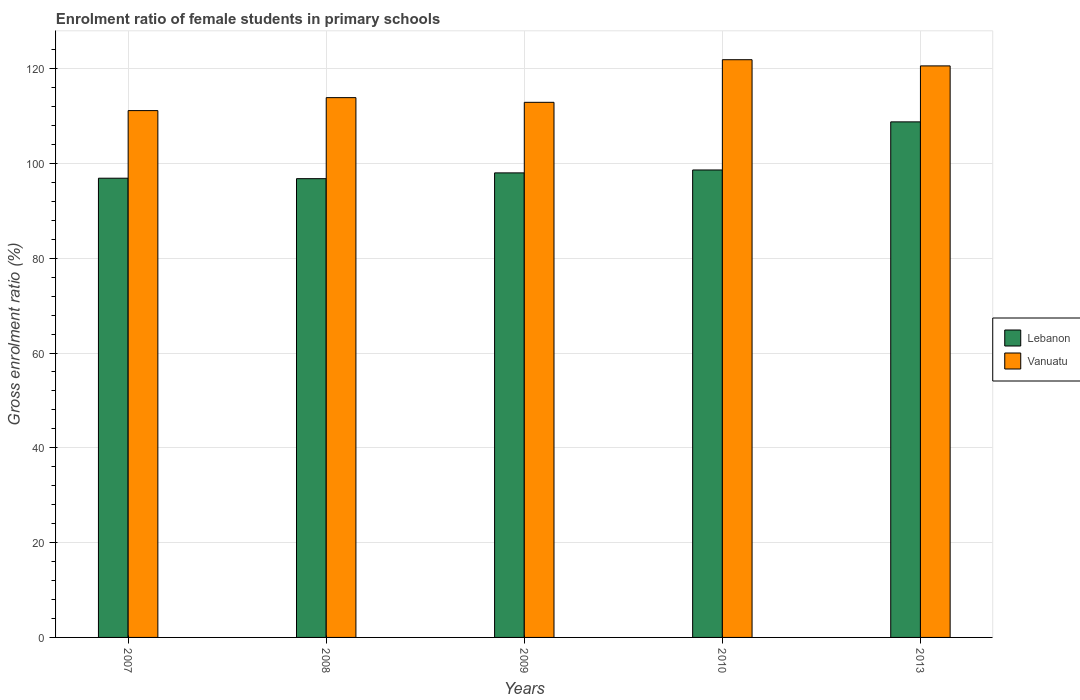How many different coloured bars are there?
Keep it short and to the point. 2. How many groups of bars are there?
Offer a very short reply. 5. How many bars are there on the 3rd tick from the right?
Make the answer very short. 2. In how many cases, is the number of bars for a given year not equal to the number of legend labels?
Offer a very short reply. 0. What is the enrolment ratio of female students in primary schools in Vanuatu in 2013?
Offer a terse response. 120.58. Across all years, what is the maximum enrolment ratio of female students in primary schools in Vanuatu?
Ensure brevity in your answer.  121.88. Across all years, what is the minimum enrolment ratio of female students in primary schools in Vanuatu?
Keep it short and to the point. 111.14. In which year was the enrolment ratio of female students in primary schools in Lebanon maximum?
Ensure brevity in your answer.  2013. In which year was the enrolment ratio of female students in primary schools in Vanuatu minimum?
Offer a terse response. 2007. What is the total enrolment ratio of female students in primary schools in Lebanon in the graph?
Keep it short and to the point. 499.07. What is the difference between the enrolment ratio of female students in primary schools in Vanuatu in 2007 and that in 2009?
Offer a terse response. -1.75. What is the difference between the enrolment ratio of female students in primary schools in Vanuatu in 2010 and the enrolment ratio of female students in primary schools in Lebanon in 2009?
Your answer should be very brief. 23.88. What is the average enrolment ratio of female students in primary schools in Lebanon per year?
Your answer should be very brief. 99.81. In the year 2007, what is the difference between the enrolment ratio of female students in primary schools in Lebanon and enrolment ratio of female students in primary schools in Vanuatu?
Provide a short and direct response. -14.26. In how many years, is the enrolment ratio of female students in primary schools in Vanuatu greater than 20 %?
Your answer should be compact. 5. What is the ratio of the enrolment ratio of female students in primary schools in Vanuatu in 2007 to that in 2008?
Ensure brevity in your answer.  0.98. What is the difference between the highest and the second highest enrolment ratio of female students in primary schools in Vanuatu?
Offer a very short reply. 1.31. What is the difference between the highest and the lowest enrolment ratio of female students in primary schools in Vanuatu?
Your answer should be very brief. 10.74. Is the sum of the enrolment ratio of female students in primary schools in Lebanon in 2008 and 2013 greater than the maximum enrolment ratio of female students in primary schools in Vanuatu across all years?
Your answer should be compact. Yes. What does the 2nd bar from the left in 2010 represents?
Your answer should be very brief. Vanuatu. What does the 1st bar from the right in 2007 represents?
Ensure brevity in your answer.  Vanuatu. Are all the bars in the graph horizontal?
Ensure brevity in your answer.  No. What is the difference between two consecutive major ticks on the Y-axis?
Give a very brief answer. 20. Are the values on the major ticks of Y-axis written in scientific E-notation?
Your answer should be very brief. No. Does the graph contain any zero values?
Your answer should be very brief. No. How many legend labels are there?
Make the answer very short. 2. How are the legend labels stacked?
Keep it short and to the point. Vertical. What is the title of the graph?
Keep it short and to the point. Enrolment ratio of female students in primary schools. What is the label or title of the Y-axis?
Offer a terse response. Gross enrolment ratio (%). What is the Gross enrolment ratio (%) in Lebanon in 2007?
Keep it short and to the point. 96.88. What is the Gross enrolment ratio (%) of Vanuatu in 2007?
Provide a short and direct response. 111.14. What is the Gross enrolment ratio (%) in Lebanon in 2008?
Your response must be concise. 96.79. What is the Gross enrolment ratio (%) of Vanuatu in 2008?
Your response must be concise. 113.88. What is the Gross enrolment ratio (%) of Lebanon in 2009?
Ensure brevity in your answer.  98.01. What is the Gross enrolment ratio (%) of Vanuatu in 2009?
Provide a succinct answer. 112.89. What is the Gross enrolment ratio (%) in Lebanon in 2010?
Ensure brevity in your answer.  98.62. What is the Gross enrolment ratio (%) of Vanuatu in 2010?
Give a very brief answer. 121.88. What is the Gross enrolment ratio (%) in Lebanon in 2013?
Offer a terse response. 108.77. What is the Gross enrolment ratio (%) in Vanuatu in 2013?
Ensure brevity in your answer.  120.58. Across all years, what is the maximum Gross enrolment ratio (%) of Lebanon?
Make the answer very short. 108.77. Across all years, what is the maximum Gross enrolment ratio (%) in Vanuatu?
Offer a terse response. 121.88. Across all years, what is the minimum Gross enrolment ratio (%) in Lebanon?
Give a very brief answer. 96.79. Across all years, what is the minimum Gross enrolment ratio (%) of Vanuatu?
Your answer should be compact. 111.14. What is the total Gross enrolment ratio (%) of Lebanon in the graph?
Give a very brief answer. 499.07. What is the total Gross enrolment ratio (%) of Vanuatu in the graph?
Offer a terse response. 580.38. What is the difference between the Gross enrolment ratio (%) in Lebanon in 2007 and that in 2008?
Make the answer very short. 0.09. What is the difference between the Gross enrolment ratio (%) of Vanuatu in 2007 and that in 2008?
Provide a succinct answer. -2.74. What is the difference between the Gross enrolment ratio (%) of Lebanon in 2007 and that in 2009?
Make the answer very short. -1.12. What is the difference between the Gross enrolment ratio (%) in Vanuatu in 2007 and that in 2009?
Keep it short and to the point. -1.75. What is the difference between the Gross enrolment ratio (%) in Lebanon in 2007 and that in 2010?
Offer a very short reply. -1.74. What is the difference between the Gross enrolment ratio (%) in Vanuatu in 2007 and that in 2010?
Ensure brevity in your answer.  -10.74. What is the difference between the Gross enrolment ratio (%) in Lebanon in 2007 and that in 2013?
Provide a succinct answer. -11.89. What is the difference between the Gross enrolment ratio (%) in Vanuatu in 2007 and that in 2013?
Your response must be concise. -9.43. What is the difference between the Gross enrolment ratio (%) in Lebanon in 2008 and that in 2009?
Your answer should be very brief. -1.22. What is the difference between the Gross enrolment ratio (%) of Vanuatu in 2008 and that in 2009?
Keep it short and to the point. 0.99. What is the difference between the Gross enrolment ratio (%) of Lebanon in 2008 and that in 2010?
Provide a succinct answer. -1.83. What is the difference between the Gross enrolment ratio (%) of Vanuatu in 2008 and that in 2010?
Provide a short and direct response. -8. What is the difference between the Gross enrolment ratio (%) in Lebanon in 2008 and that in 2013?
Your answer should be very brief. -11.98. What is the difference between the Gross enrolment ratio (%) in Vanuatu in 2008 and that in 2013?
Offer a terse response. -6.7. What is the difference between the Gross enrolment ratio (%) in Lebanon in 2009 and that in 2010?
Your answer should be compact. -0.61. What is the difference between the Gross enrolment ratio (%) in Vanuatu in 2009 and that in 2010?
Offer a very short reply. -8.99. What is the difference between the Gross enrolment ratio (%) in Lebanon in 2009 and that in 2013?
Provide a succinct answer. -10.77. What is the difference between the Gross enrolment ratio (%) of Vanuatu in 2009 and that in 2013?
Offer a terse response. -7.69. What is the difference between the Gross enrolment ratio (%) of Lebanon in 2010 and that in 2013?
Provide a succinct answer. -10.15. What is the difference between the Gross enrolment ratio (%) of Vanuatu in 2010 and that in 2013?
Your response must be concise. 1.31. What is the difference between the Gross enrolment ratio (%) of Lebanon in 2007 and the Gross enrolment ratio (%) of Vanuatu in 2008?
Your answer should be compact. -17. What is the difference between the Gross enrolment ratio (%) of Lebanon in 2007 and the Gross enrolment ratio (%) of Vanuatu in 2009?
Your response must be concise. -16.01. What is the difference between the Gross enrolment ratio (%) of Lebanon in 2007 and the Gross enrolment ratio (%) of Vanuatu in 2010?
Offer a very short reply. -25. What is the difference between the Gross enrolment ratio (%) of Lebanon in 2007 and the Gross enrolment ratio (%) of Vanuatu in 2013?
Your answer should be compact. -23.7. What is the difference between the Gross enrolment ratio (%) of Lebanon in 2008 and the Gross enrolment ratio (%) of Vanuatu in 2009?
Offer a very short reply. -16.1. What is the difference between the Gross enrolment ratio (%) in Lebanon in 2008 and the Gross enrolment ratio (%) in Vanuatu in 2010?
Your answer should be very brief. -25.09. What is the difference between the Gross enrolment ratio (%) of Lebanon in 2008 and the Gross enrolment ratio (%) of Vanuatu in 2013?
Make the answer very short. -23.79. What is the difference between the Gross enrolment ratio (%) of Lebanon in 2009 and the Gross enrolment ratio (%) of Vanuatu in 2010?
Your response must be concise. -23.88. What is the difference between the Gross enrolment ratio (%) of Lebanon in 2009 and the Gross enrolment ratio (%) of Vanuatu in 2013?
Ensure brevity in your answer.  -22.57. What is the difference between the Gross enrolment ratio (%) in Lebanon in 2010 and the Gross enrolment ratio (%) in Vanuatu in 2013?
Give a very brief answer. -21.96. What is the average Gross enrolment ratio (%) in Lebanon per year?
Offer a terse response. 99.81. What is the average Gross enrolment ratio (%) in Vanuatu per year?
Provide a succinct answer. 116.08. In the year 2007, what is the difference between the Gross enrolment ratio (%) in Lebanon and Gross enrolment ratio (%) in Vanuatu?
Provide a succinct answer. -14.26. In the year 2008, what is the difference between the Gross enrolment ratio (%) of Lebanon and Gross enrolment ratio (%) of Vanuatu?
Your answer should be compact. -17.09. In the year 2009, what is the difference between the Gross enrolment ratio (%) in Lebanon and Gross enrolment ratio (%) in Vanuatu?
Make the answer very short. -14.89. In the year 2010, what is the difference between the Gross enrolment ratio (%) in Lebanon and Gross enrolment ratio (%) in Vanuatu?
Make the answer very short. -23.26. In the year 2013, what is the difference between the Gross enrolment ratio (%) in Lebanon and Gross enrolment ratio (%) in Vanuatu?
Ensure brevity in your answer.  -11.81. What is the ratio of the Gross enrolment ratio (%) in Lebanon in 2007 to that in 2008?
Your answer should be compact. 1. What is the ratio of the Gross enrolment ratio (%) of Vanuatu in 2007 to that in 2009?
Give a very brief answer. 0.98. What is the ratio of the Gross enrolment ratio (%) of Lebanon in 2007 to that in 2010?
Your response must be concise. 0.98. What is the ratio of the Gross enrolment ratio (%) of Vanuatu in 2007 to that in 2010?
Keep it short and to the point. 0.91. What is the ratio of the Gross enrolment ratio (%) in Lebanon in 2007 to that in 2013?
Offer a very short reply. 0.89. What is the ratio of the Gross enrolment ratio (%) of Vanuatu in 2007 to that in 2013?
Your answer should be very brief. 0.92. What is the ratio of the Gross enrolment ratio (%) in Lebanon in 2008 to that in 2009?
Your answer should be compact. 0.99. What is the ratio of the Gross enrolment ratio (%) of Vanuatu in 2008 to that in 2009?
Offer a very short reply. 1.01. What is the ratio of the Gross enrolment ratio (%) of Lebanon in 2008 to that in 2010?
Your answer should be very brief. 0.98. What is the ratio of the Gross enrolment ratio (%) in Vanuatu in 2008 to that in 2010?
Give a very brief answer. 0.93. What is the ratio of the Gross enrolment ratio (%) of Lebanon in 2008 to that in 2013?
Provide a succinct answer. 0.89. What is the ratio of the Gross enrolment ratio (%) in Vanuatu in 2008 to that in 2013?
Offer a terse response. 0.94. What is the ratio of the Gross enrolment ratio (%) in Lebanon in 2009 to that in 2010?
Offer a very short reply. 0.99. What is the ratio of the Gross enrolment ratio (%) in Vanuatu in 2009 to that in 2010?
Offer a very short reply. 0.93. What is the ratio of the Gross enrolment ratio (%) in Lebanon in 2009 to that in 2013?
Ensure brevity in your answer.  0.9. What is the ratio of the Gross enrolment ratio (%) of Vanuatu in 2009 to that in 2013?
Offer a terse response. 0.94. What is the ratio of the Gross enrolment ratio (%) of Lebanon in 2010 to that in 2013?
Offer a terse response. 0.91. What is the ratio of the Gross enrolment ratio (%) of Vanuatu in 2010 to that in 2013?
Offer a terse response. 1.01. What is the difference between the highest and the second highest Gross enrolment ratio (%) in Lebanon?
Keep it short and to the point. 10.15. What is the difference between the highest and the second highest Gross enrolment ratio (%) in Vanuatu?
Make the answer very short. 1.31. What is the difference between the highest and the lowest Gross enrolment ratio (%) in Lebanon?
Provide a succinct answer. 11.98. What is the difference between the highest and the lowest Gross enrolment ratio (%) in Vanuatu?
Make the answer very short. 10.74. 